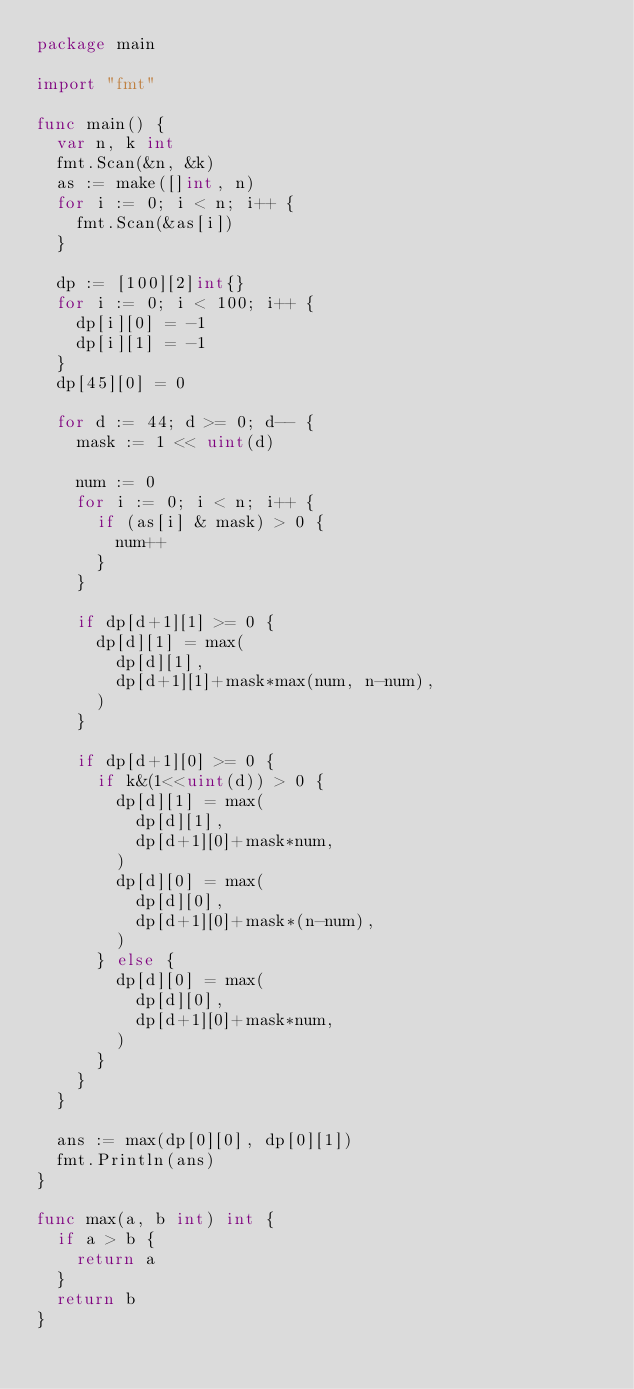<code> <loc_0><loc_0><loc_500><loc_500><_Go_>package main

import "fmt"

func main() {
	var n, k int
	fmt.Scan(&n, &k)
	as := make([]int, n)
	for i := 0; i < n; i++ {
		fmt.Scan(&as[i])
	}

	dp := [100][2]int{}
	for i := 0; i < 100; i++ {
		dp[i][0] = -1
		dp[i][1] = -1
	}
	dp[45][0] = 0

	for d := 44; d >= 0; d-- {
		mask := 1 << uint(d)

		num := 0
		for i := 0; i < n; i++ {
			if (as[i] & mask) > 0 {
				num++
			}
		}

		if dp[d+1][1] >= 0 {
			dp[d][1] = max(
				dp[d][1],
				dp[d+1][1]+mask*max(num, n-num),
			)
		}

		if dp[d+1][0] >= 0 {
			if k&(1<<uint(d)) > 0 {
				dp[d][1] = max(
					dp[d][1],
					dp[d+1][0]+mask*num,
				)
				dp[d][0] = max(
					dp[d][0],
					dp[d+1][0]+mask*(n-num),
				)
			} else {
				dp[d][0] = max(
					dp[d][0],
					dp[d+1][0]+mask*num,
				)
			}
		}
	}

	ans := max(dp[0][0], dp[0][1])
	fmt.Println(ans)
}

func max(a, b int) int {
	if a > b {
		return a
	}
	return b
}
</code> 